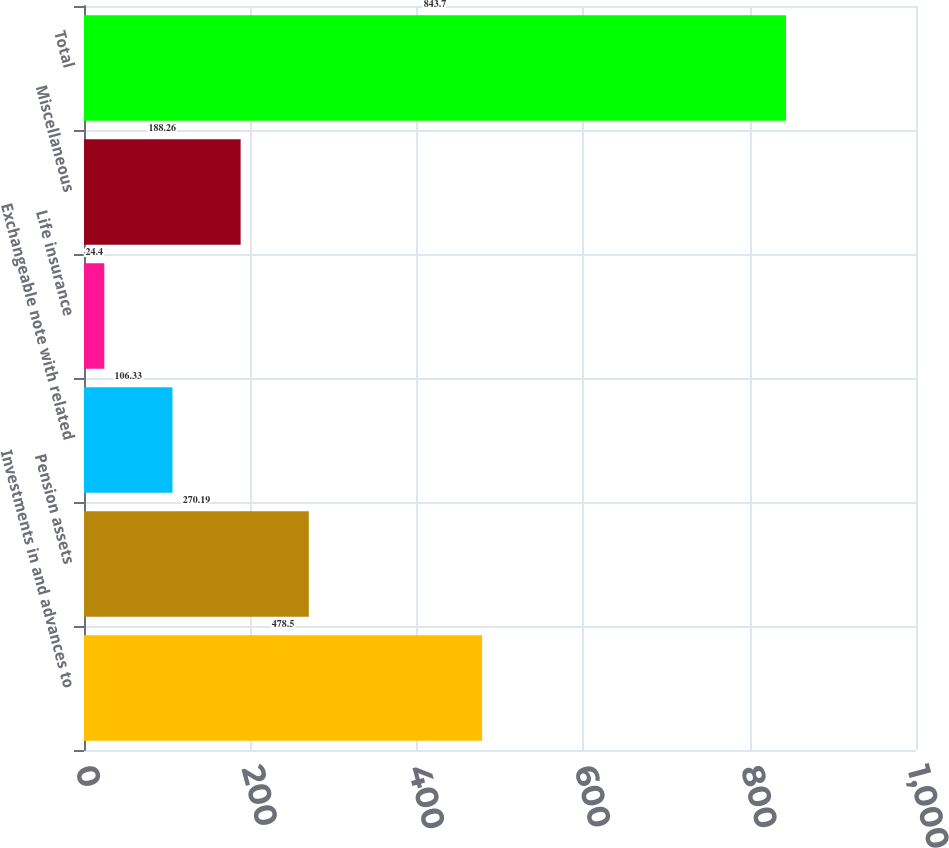<chart> <loc_0><loc_0><loc_500><loc_500><bar_chart><fcel>Investments in and advances to<fcel>Pension assets<fcel>Exchangeable note with related<fcel>Life insurance<fcel>Miscellaneous<fcel>Total<nl><fcel>478.5<fcel>270.19<fcel>106.33<fcel>24.4<fcel>188.26<fcel>843.7<nl></chart> 